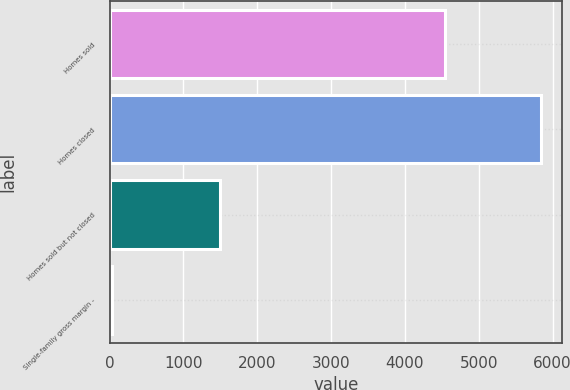<chart> <loc_0><loc_0><loc_500><loc_500><bar_chart><fcel>Homes sold<fcel>Homes closed<fcel>Homes sold but not closed<fcel>Single-family gross margin -<nl><fcel>4541<fcel>5836<fcel>1499<fcel>27.6<nl></chart> 